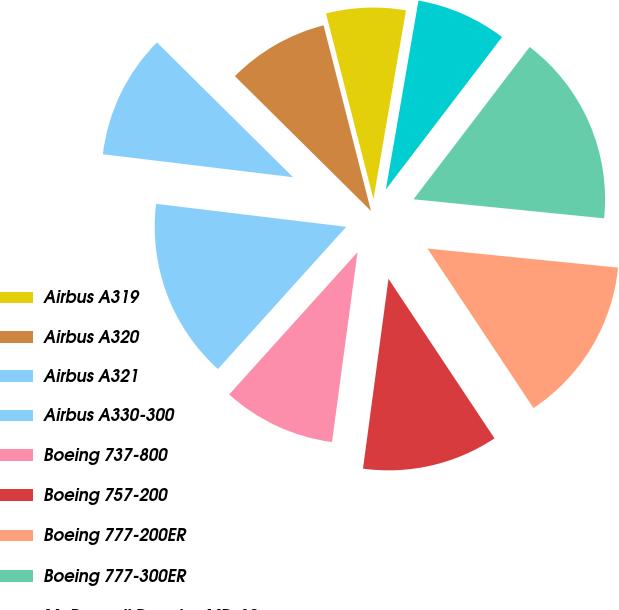<chart> <loc_0><loc_0><loc_500><loc_500><pie_chart><fcel>Airbus A319<fcel>Airbus A320<fcel>Airbus A321<fcel>Airbus A330-300<fcel>Boeing 737-800<fcel>Boeing 757-200<fcel>Boeing 777-200ER<fcel>Boeing 777-300ER<fcel>McDonnell Douglas MD-80<nl><fcel>6.7%<fcel>8.6%<fcel>10.51%<fcel>15.23%<fcel>9.56%<fcel>11.46%<fcel>14.08%<fcel>16.22%<fcel>7.65%<nl></chart> 